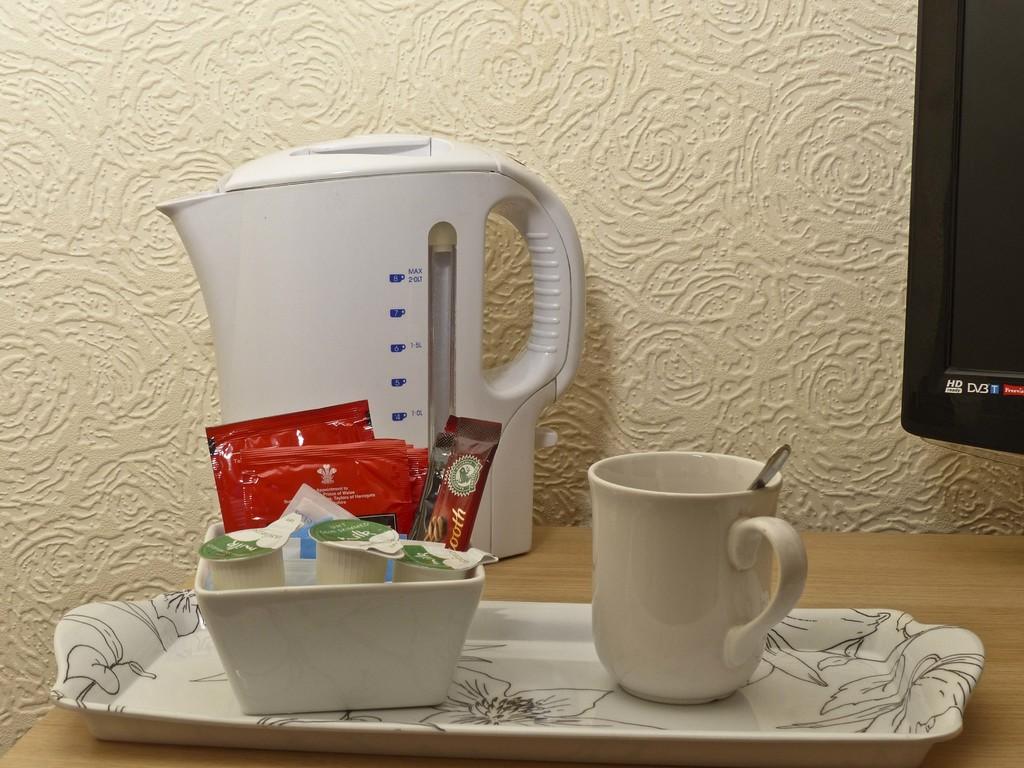Is that an hd tv?
Your answer should be compact. Yes. What does the text say in the t.v.?
Make the answer very short. Unanswerable. 